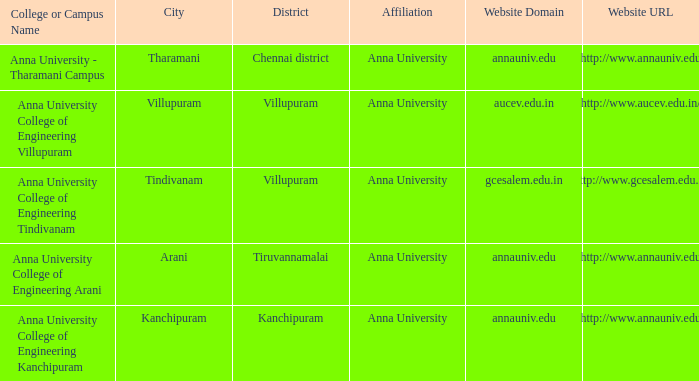What District has a College or Campus Name of anna university college of engineering kanchipuram? Kanchipuram. 